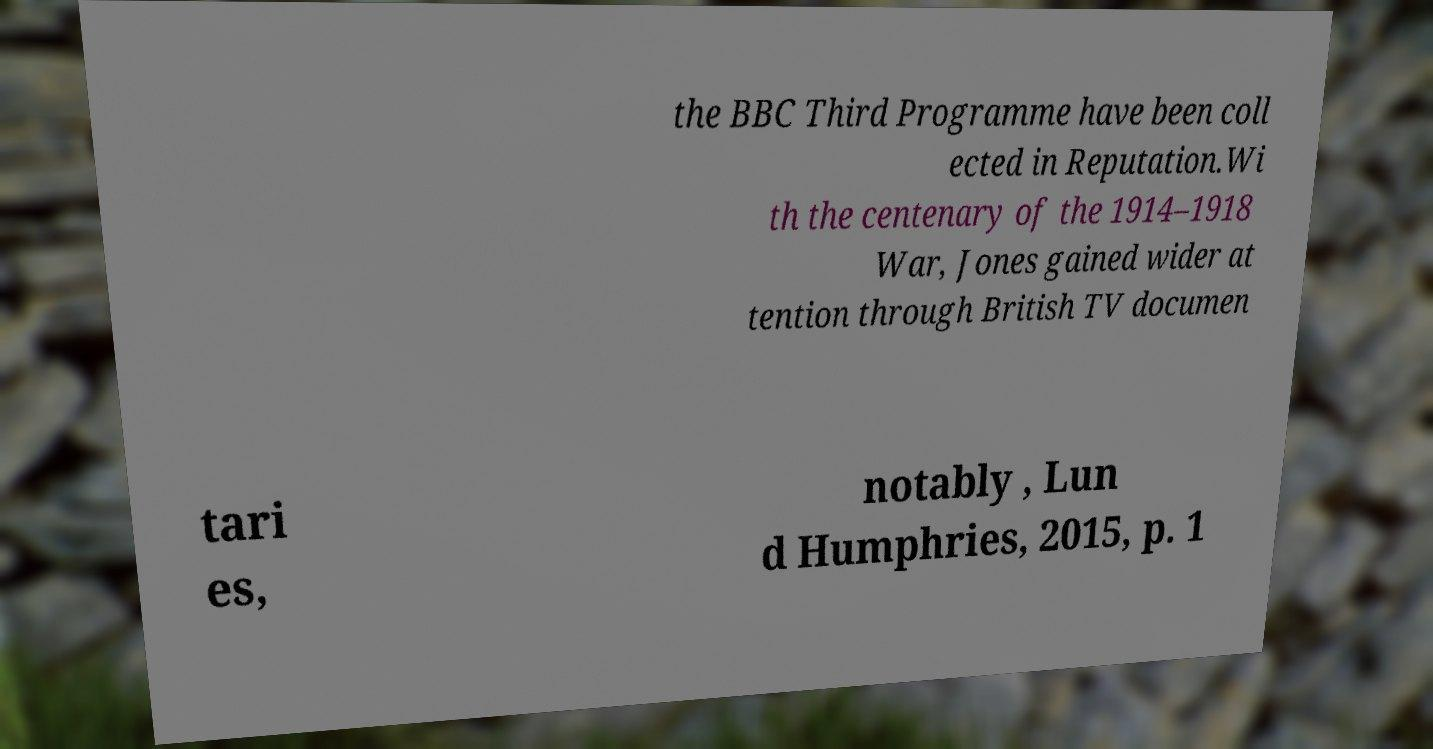Can you read and provide the text displayed in the image?This photo seems to have some interesting text. Can you extract and type it out for me? the BBC Third Programme have been coll ected in Reputation.Wi th the centenary of the 1914–1918 War, Jones gained wider at tention through British TV documen tari es, notably , Lun d Humphries, 2015, p. 1 